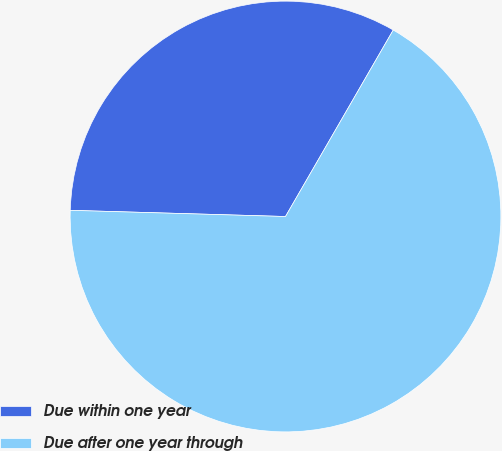Convert chart. <chart><loc_0><loc_0><loc_500><loc_500><pie_chart><fcel>Due within one year<fcel>Due after one year through<nl><fcel>32.88%<fcel>67.12%<nl></chart> 